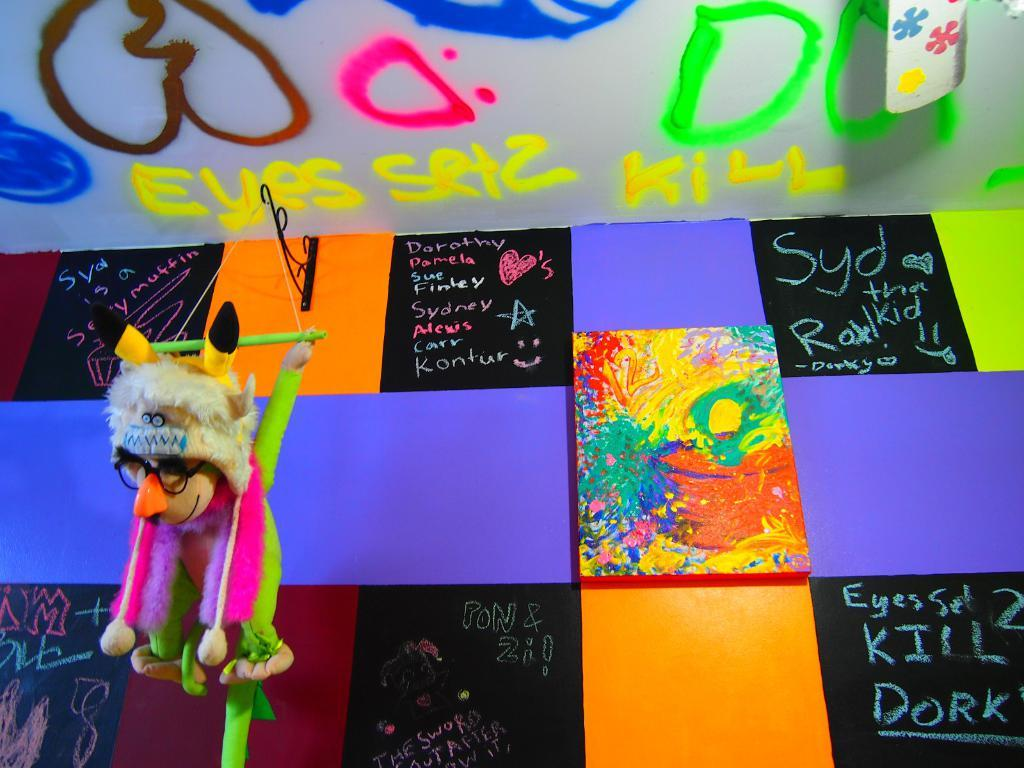Provide a one-sentence caption for the provided image. Colored tiles are between chalkboard tiles with people's names on them including Dorothy, Pamela, and Alexis. 